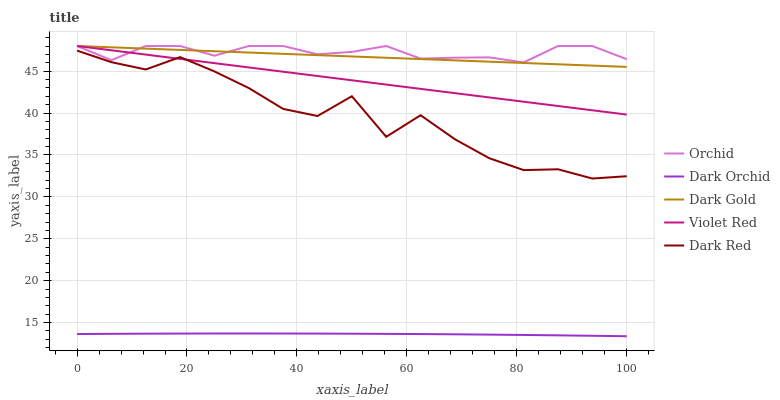Does Violet Red have the minimum area under the curve?
Answer yes or no. No. Does Violet Red have the maximum area under the curve?
Answer yes or no. No. Is Dark Gold the smoothest?
Answer yes or no. No. Is Dark Gold the roughest?
Answer yes or no. No. Does Violet Red have the lowest value?
Answer yes or no. No. Does Dark Orchid have the highest value?
Answer yes or no. No. Is Dark Red less than Orchid?
Answer yes or no. Yes. Is Dark Gold greater than Dark Red?
Answer yes or no. Yes. Does Dark Red intersect Orchid?
Answer yes or no. No. 